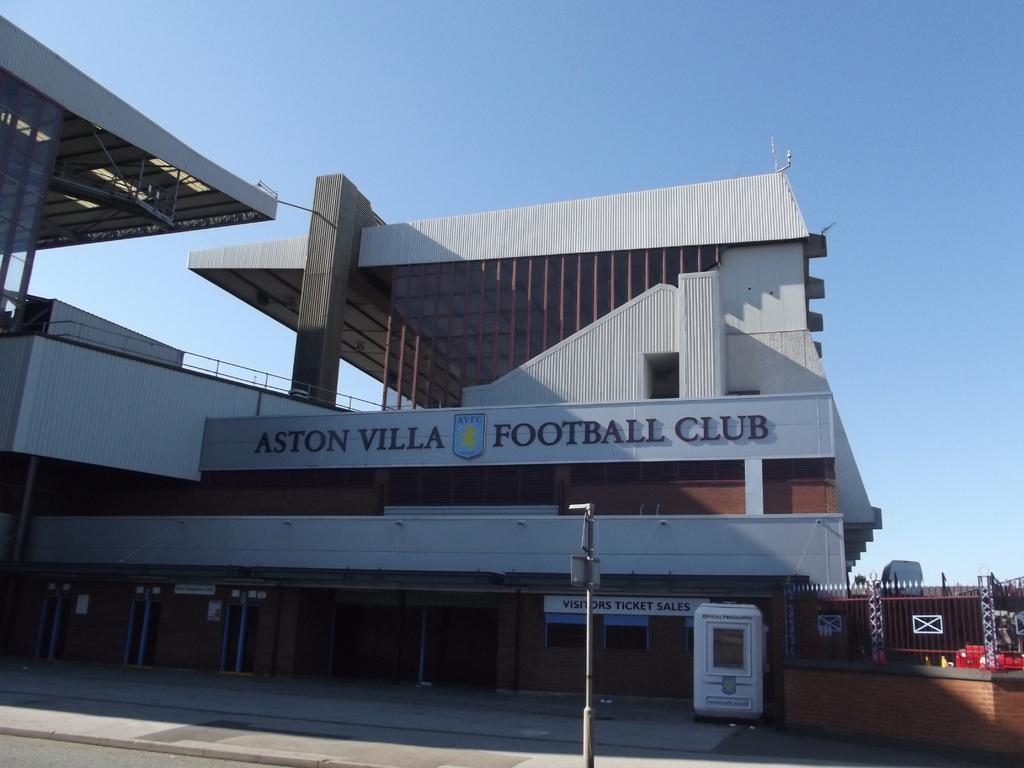What type of structures can be seen in the image? There are buildings in the image. What is located near the buildings? There is a fence and a pole in the image. Can you read anything on the buildings? Yes, there is something written on a building. What can be seen in the background of the image? The sky is visible in the background of the image. How many snails can be seen climbing the pole in the image? There are no snails present in the image, and therefore no snails can be seen climbing the pole. 